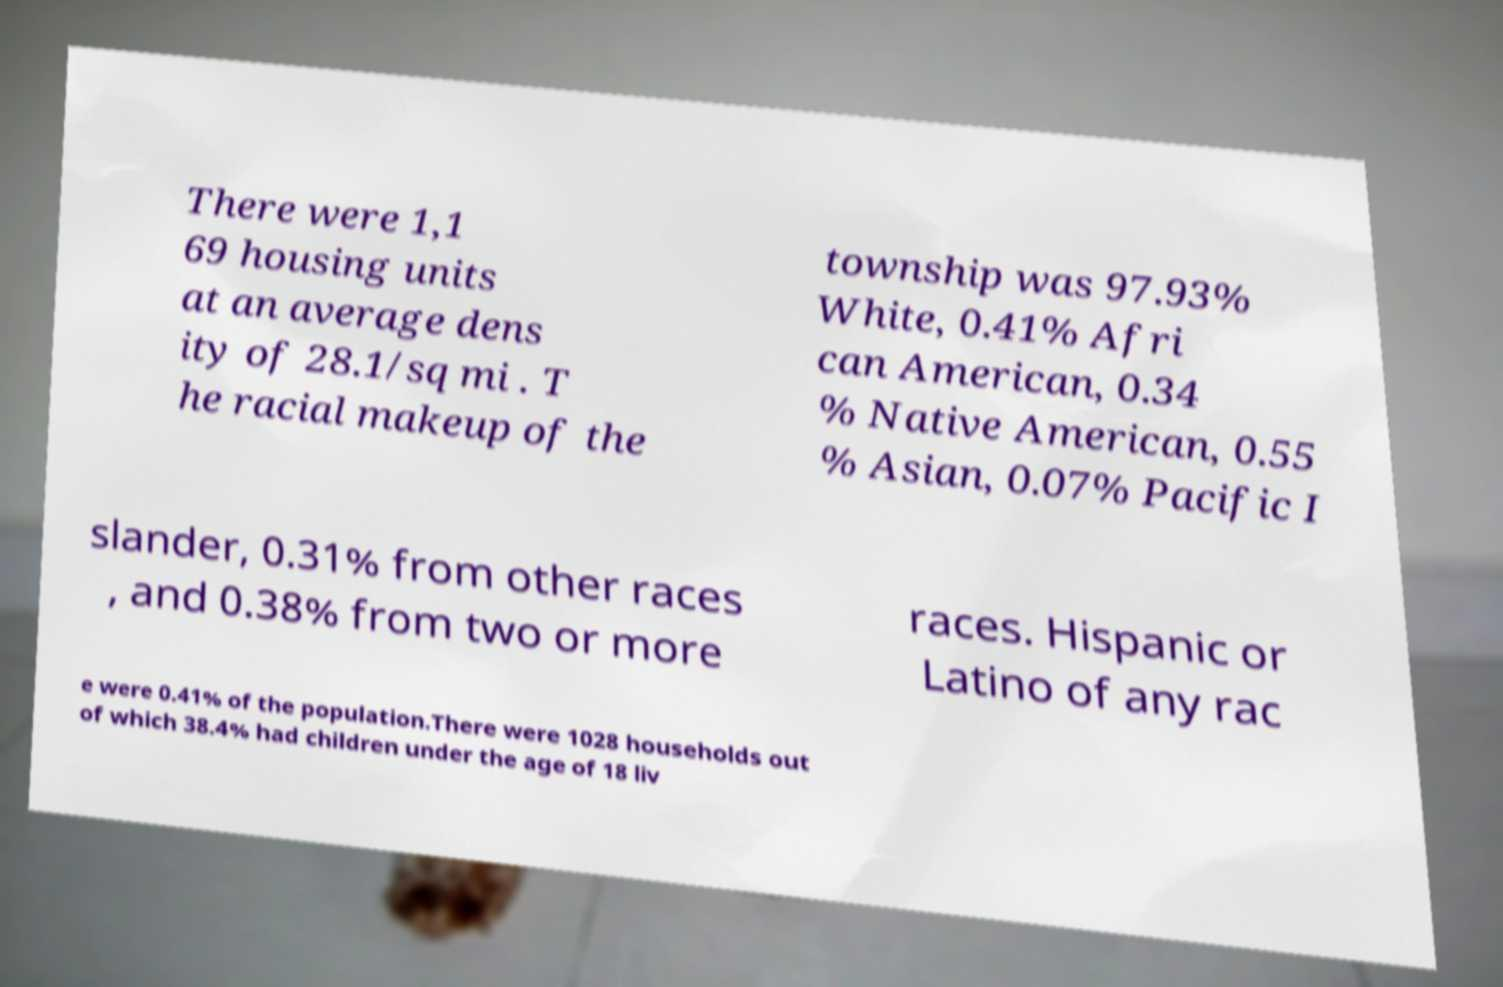Can you accurately transcribe the text from the provided image for me? There were 1,1 69 housing units at an average dens ity of 28.1/sq mi . T he racial makeup of the township was 97.93% White, 0.41% Afri can American, 0.34 % Native American, 0.55 % Asian, 0.07% Pacific I slander, 0.31% from other races , and 0.38% from two or more races. Hispanic or Latino of any rac e were 0.41% of the population.There were 1028 households out of which 38.4% had children under the age of 18 liv 